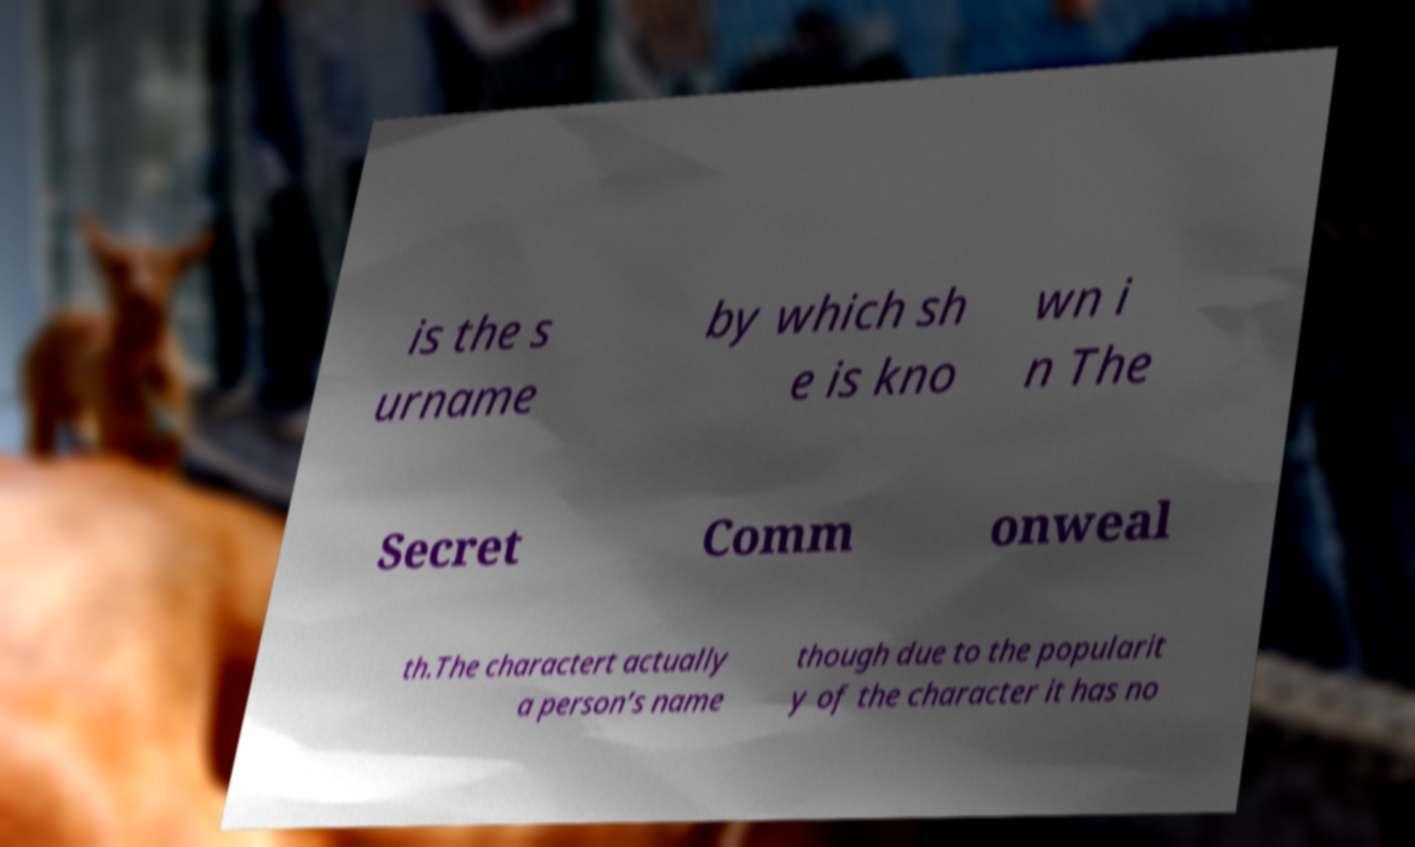Could you assist in decoding the text presented in this image and type it out clearly? is the s urname by which sh e is kno wn i n The Secret Comm onweal th.The charactert actually a person’s name though due to the popularit y of the character it has no 